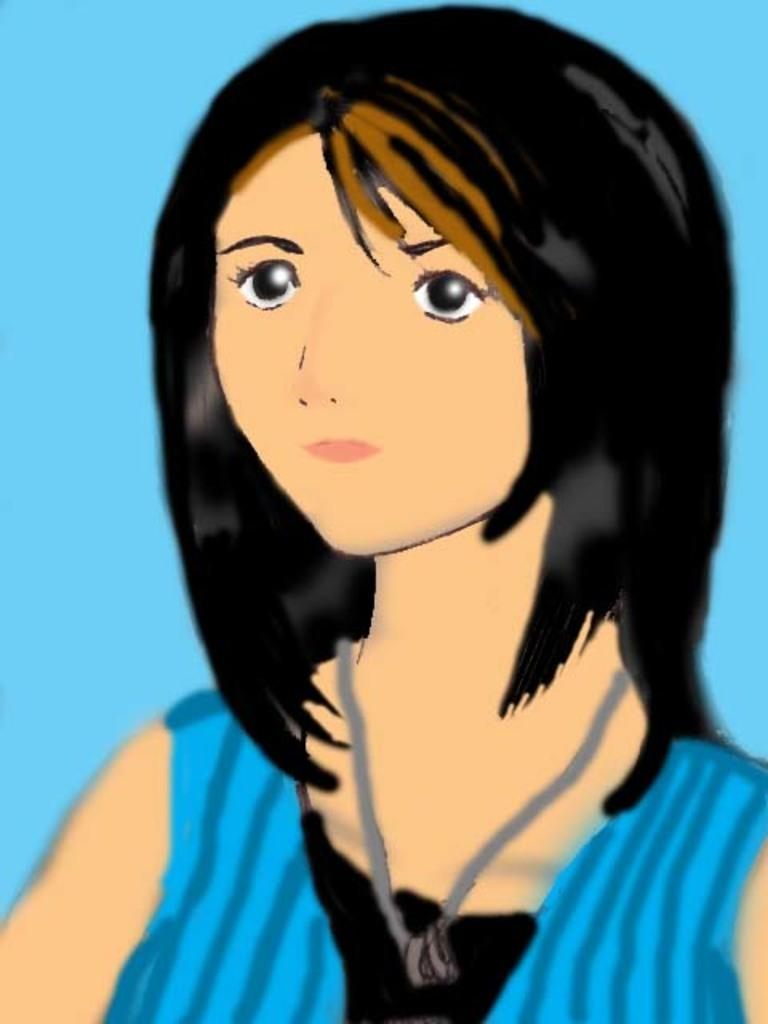What type of image is being depicted? The image is an animation. Who is the main character in the animation? There is a girl in the animation. What is the girl wearing in the animation? The girl is wearing a blue dress. How does the girl in the animation sleep while wearing her blue dress? The animation does not depict the girl sleeping; it only shows her wearing a blue dress. What other things can be seen in the animation besides the girl? The provided facts do not mention any other things present in the animation besides the girl. 